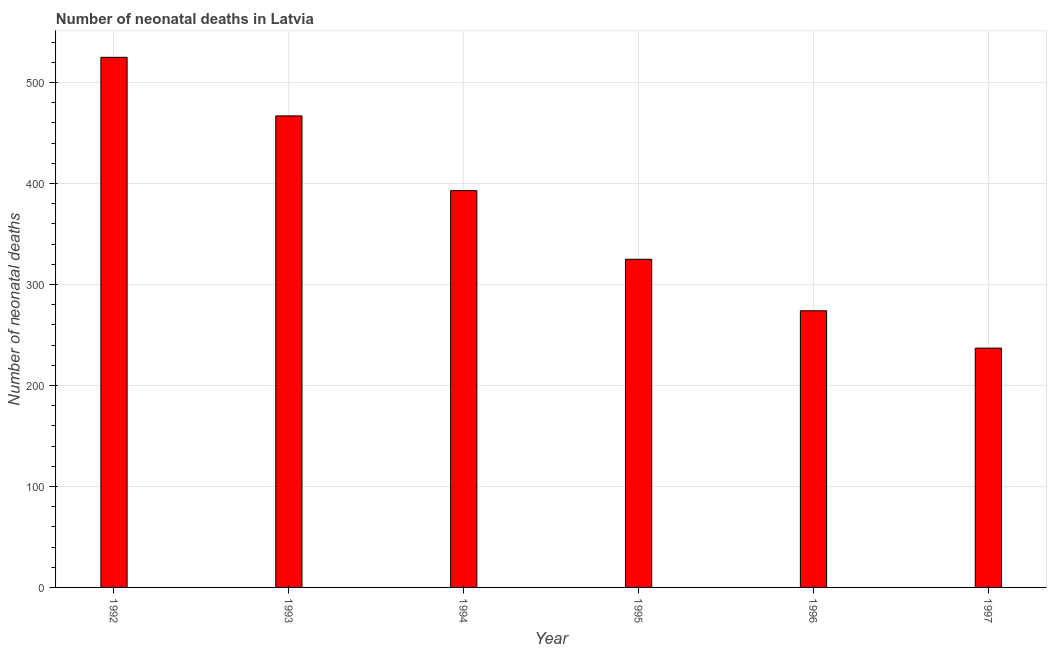Does the graph contain grids?
Your answer should be compact. Yes. What is the title of the graph?
Offer a terse response. Number of neonatal deaths in Latvia. What is the label or title of the X-axis?
Offer a terse response. Year. What is the label or title of the Y-axis?
Offer a very short reply. Number of neonatal deaths. What is the number of neonatal deaths in 1994?
Keep it short and to the point. 393. Across all years, what is the maximum number of neonatal deaths?
Provide a succinct answer. 525. Across all years, what is the minimum number of neonatal deaths?
Offer a very short reply. 237. In which year was the number of neonatal deaths minimum?
Offer a very short reply. 1997. What is the sum of the number of neonatal deaths?
Ensure brevity in your answer.  2221. What is the difference between the number of neonatal deaths in 1993 and 1994?
Provide a short and direct response. 74. What is the average number of neonatal deaths per year?
Your answer should be compact. 370. What is the median number of neonatal deaths?
Your answer should be compact. 359. What is the ratio of the number of neonatal deaths in 1996 to that in 1997?
Offer a very short reply. 1.16. Is the number of neonatal deaths in 1992 less than that in 1995?
Your answer should be very brief. No. Is the difference between the number of neonatal deaths in 1993 and 1995 greater than the difference between any two years?
Offer a terse response. No. What is the difference between the highest and the second highest number of neonatal deaths?
Provide a short and direct response. 58. Is the sum of the number of neonatal deaths in 1994 and 1996 greater than the maximum number of neonatal deaths across all years?
Give a very brief answer. Yes. What is the difference between the highest and the lowest number of neonatal deaths?
Your answer should be very brief. 288. How many bars are there?
Your answer should be very brief. 6. Are all the bars in the graph horizontal?
Keep it short and to the point. No. How many years are there in the graph?
Make the answer very short. 6. Are the values on the major ticks of Y-axis written in scientific E-notation?
Your answer should be compact. No. What is the Number of neonatal deaths in 1992?
Give a very brief answer. 525. What is the Number of neonatal deaths of 1993?
Ensure brevity in your answer.  467. What is the Number of neonatal deaths of 1994?
Keep it short and to the point. 393. What is the Number of neonatal deaths of 1995?
Offer a very short reply. 325. What is the Number of neonatal deaths in 1996?
Give a very brief answer. 274. What is the Number of neonatal deaths in 1997?
Make the answer very short. 237. What is the difference between the Number of neonatal deaths in 1992 and 1994?
Your response must be concise. 132. What is the difference between the Number of neonatal deaths in 1992 and 1995?
Make the answer very short. 200. What is the difference between the Number of neonatal deaths in 1992 and 1996?
Your response must be concise. 251. What is the difference between the Number of neonatal deaths in 1992 and 1997?
Keep it short and to the point. 288. What is the difference between the Number of neonatal deaths in 1993 and 1995?
Your answer should be compact. 142. What is the difference between the Number of neonatal deaths in 1993 and 1996?
Offer a terse response. 193. What is the difference between the Number of neonatal deaths in 1993 and 1997?
Keep it short and to the point. 230. What is the difference between the Number of neonatal deaths in 1994 and 1995?
Give a very brief answer. 68. What is the difference between the Number of neonatal deaths in 1994 and 1996?
Give a very brief answer. 119. What is the difference between the Number of neonatal deaths in 1994 and 1997?
Offer a terse response. 156. What is the ratio of the Number of neonatal deaths in 1992 to that in 1993?
Offer a terse response. 1.12. What is the ratio of the Number of neonatal deaths in 1992 to that in 1994?
Offer a terse response. 1.34. What is the ratio of the Number of neonatal deaths in 1992 to that in 1995?
Your response must be concise. 1.61. What is the ratio of the Number of neonatal deaths in 1992 to that in 1996?
Give a very brief answer. 1.92. What is the ratio of the Number of neonatal deaths in 1992 to that in 1997?
Make the answer very short. 2.21. What is the ratio of the Number of neonatal deaths in 1993 to that in 1994?
Make the answer very short. 1.19. What is the ratio of the Number of neonatal deaths in 1993 to that in 1995?
Offer a terse response. 1.44. What is the ratio of the Number of neonatal deaths in 1993 to that in 1996?
Provide a short and direct response. 1.7. What is the ratio of the Number of neonatal deaths in 1993 to that in 1997?
Give a very brief answer. 1.97. What is the ratio of the Number of neonatal deaths in 1994 to that in 1995?
Make the answer very short. 1.21. What is the ratio of the Number of neonatal deaths in 1994 to that in 1996?
Keep it short and to the point. 1.43. What is the ratio of the Number of neonatal deaths in 1994 to that in 1997?
Keep it short and to the point. 1.66. What is the ratio of the Number of neonatal deaths in 1995 to that in 1996?
Your answer should be very brief. 1.19. What is the ratio of the Number of neonatal deaths in 1995 to that in 1997?
Offer a very short reply. 1.37. What is the ratio of the Number of neonatal deaths in 1996 to that in 1997?
Provide a short and direct response. 1.16. 